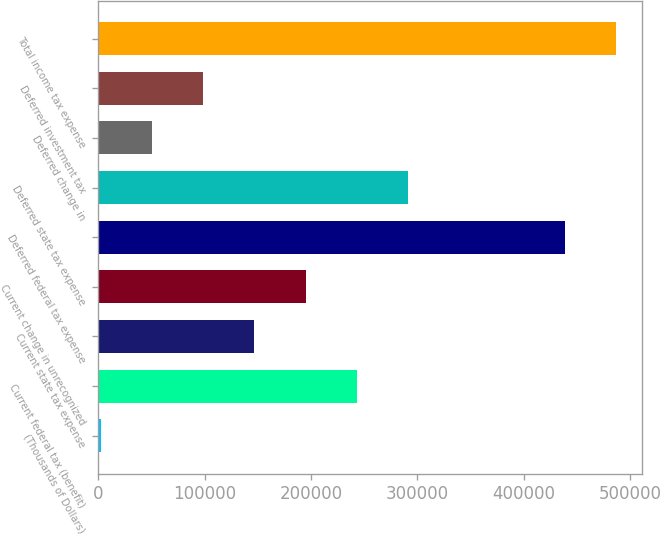<chart> <loc_0><loc_0><loc_500><loc_500><bar_chart><fcel>(Thousands of Dollars)<fcel>Current federal tax (benefit)<fcel>Current state tax expense<fcel>Current change in unrecognized<fcel>Deferred federal tax expense<fcel>Deferred state tax expense<fcel>Deferred change in<fcel>Deferred investment tax<fcel>Total income tax expense<nl><fcel>2013<fcel>242994<fcel>146602<fcel>194798<fcel>439085<fcel>291191<fcel>50209.3<fcel>98405.6<fcel>487281<nl></chart> 